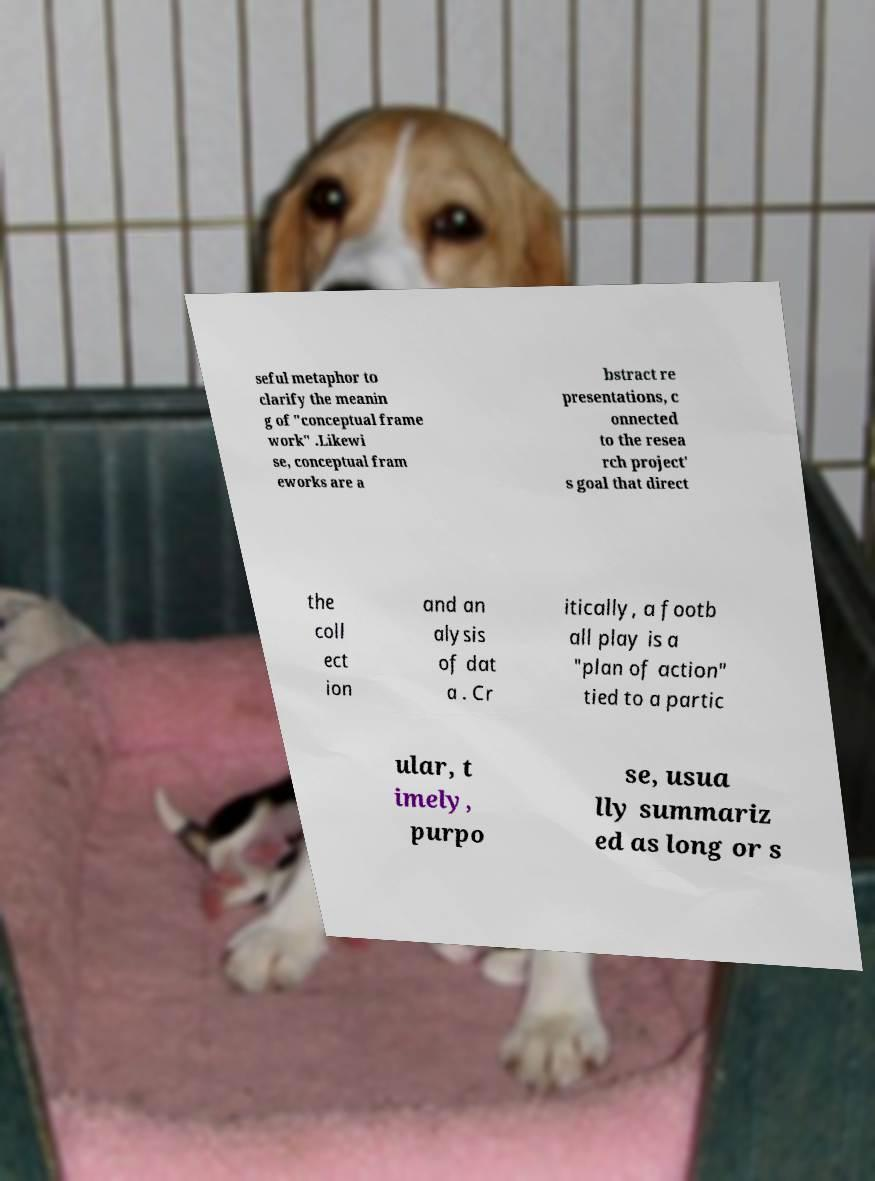For documentation purposes, I need the text within this image transcribed. Could you provide that? seful metaphor to clarify the meanin g of "conceptual frame work" .Likewi se, conceptual fram eworks are a bstract re presentations, c onnected to the resea rch project' s goal that direct the coll ect ion and an alysis of dat a . Cr itically, a footb all play is a "plan of action" tied to a partic ular, t imely, purpo se, usua lly summariz ed as long or s 